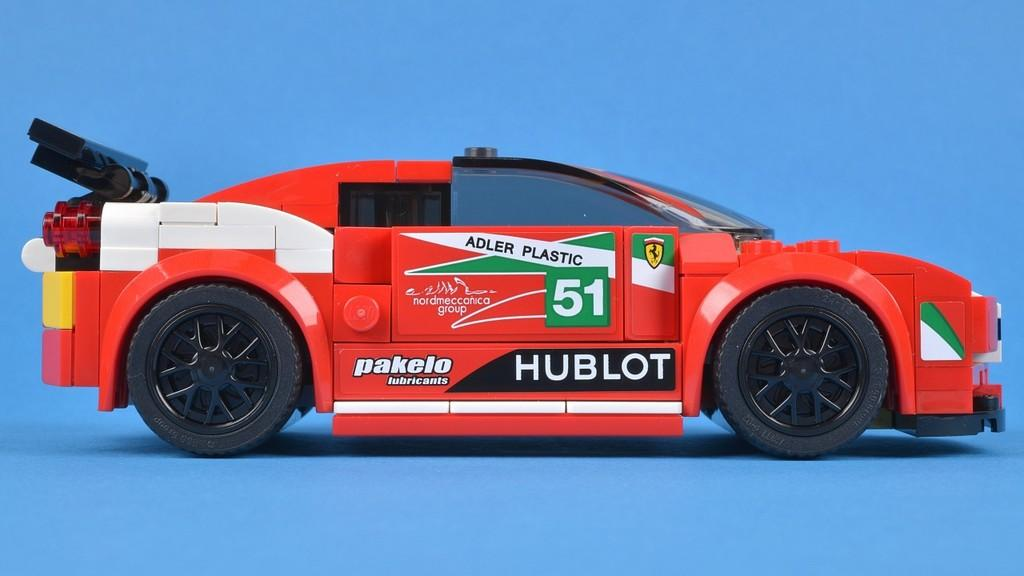What is the main subject of the image? The main subject of the image is a car toy. What is the color of the surface on which the car toy is placed? The car toy is on a blue color surface. What type of chicken is depicted in the image? There is no chicken present in the image; it features a car toy on a blue surface. 